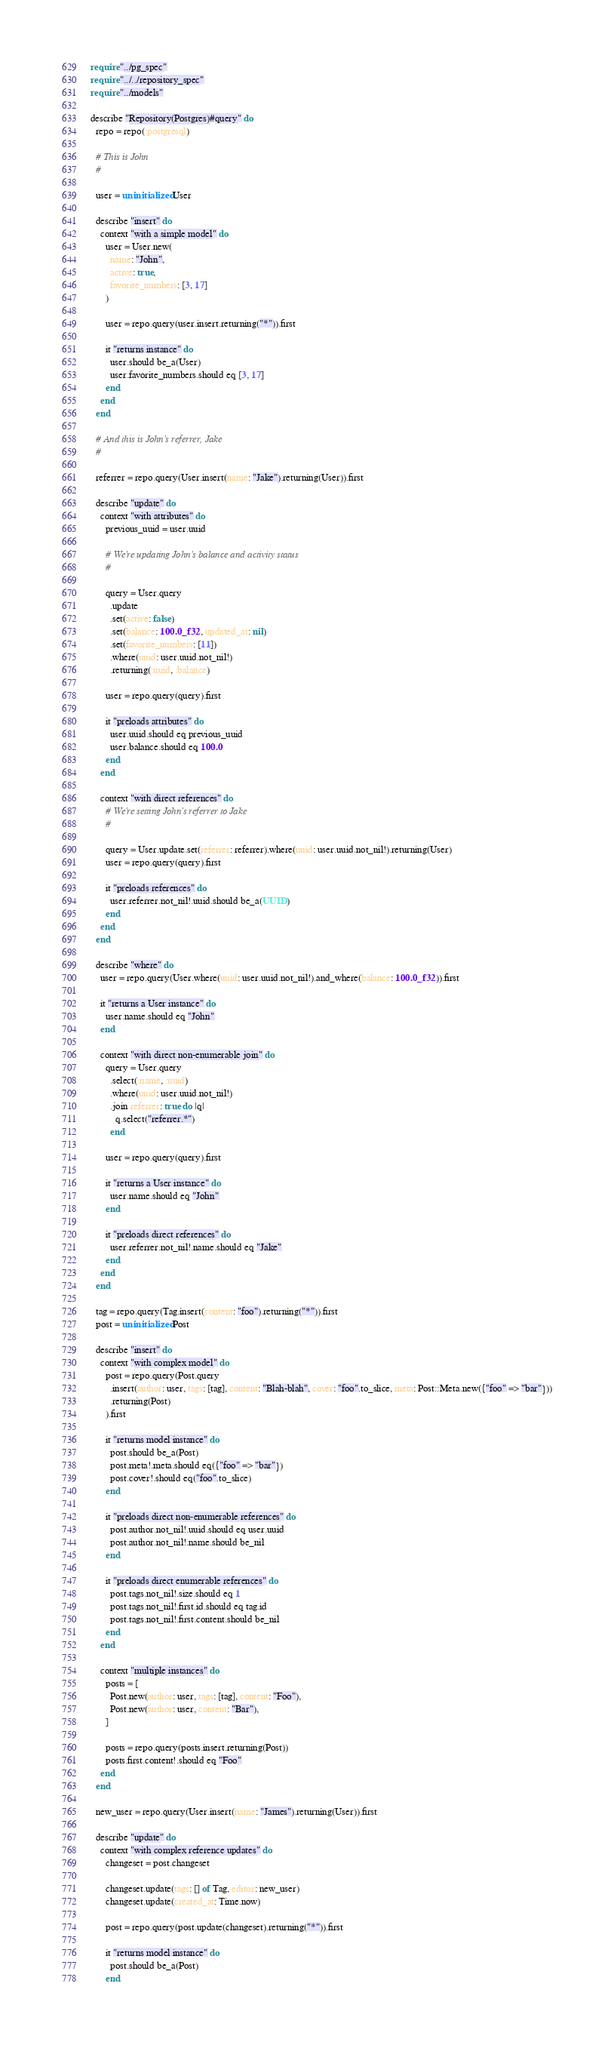Convert code to text. <code><loc_0><loc_0><loc_500><loc_500><_Crystal_>require "../pg_spec"
require "../../repository_spec"
require "../models"

describe "Repository(Postgres)#query" do
  repo = repo(:postgresql)

  # This is John
  #

  user = uninitialized User

  describe "insert" do
    context "with a simple model" do
      user = User.new(
        name: "John",
        active: true,
        favorite_numbers: [3, 17]
      )

      user = repo.query(user.insert.returning("*")).first

      it "returns instance" do
        user.should be_a(User)
        user.favorite_numbers.should eq [3, 17]
      end
    end
  end

  # And this is John's referrer, Jake
  #

  referrer = repo.query(User.insert(name: "Jake").returning(User)).first

  describe "update" do
    context "with attributes" do
      previous_uuid = user.uuid

      # We're updating John's balance and activity status
      #

      query = User.query
        .update
        .set(active: false)
        .set(balance: 100.0_f32, updated_at: nil)
        .set(favorite_numbers: [11])
        .where(uuid: user.uuid.not_nil!)
        .returning(:uuid, :balance)

      user = repo.query(query).first

      it "preloads attributes" do
        user.uuid.should eq previous_uuid
        user.balance.should eq 100.0
      end
    end

    context "with direct references" do
      # We're setting John's referrer to Jake
      #

      query = User.update.set(referrer: referrer).where(uuid: user.uuid.not_nil!).returning(User)
      user = repo.query(query).first

      it "preloads references" do
        user.referrer.not_nil!.uuid.should be_a(UUID)
      end
    end
  end

  describe "where" do
    user = repo.query(User.where(uuid: user.uuid.not_nil!).and_where(balance: 100.0_f32)).first

    it "returns a User instance" do
      user.name.should eq "John"
    end

    context "with direct non-enumerable join" do
      query = User.query
        .select(:name, :uuid)
        .where(uuid: user.uuid.not_nil!)
        .join referrer: true do |q|
          q.select("referrer.*")
        end

      user = repo.query(query).first

      it "returns a User instance" do
        user.name.should eq "John"
      end

      it "preloads direct references" do
        user.referrer.not_nil!.name.should eq "Jake"
      end
    end
  end

  tag = repo.query(Tag.insert(content: "foo").returning("*")).first
  post = uninitialized Post

  describe "insert" do
    context "with complex model" do
      post = repo.query(Post.query
        .insert(author: user, tags: [tag], content: "Blah-blah", cover: "foo".to_slice, meta: Post::Meta.new({"foo" => "bar"}))
        .returning(Post)
      ).first

      it "returns model instance" do
        post.should be_a(Post)
        post.meta!.meta.should eq({"foo" => "bar"})
        post.cover!.should eq("foo".to_slice)
      end

      it "preloads direct non-enumerable references" do
        post.author.not_nil!.uuid.should eq user.uuid
        post.author.not_nil!.name.should be_nil
      end

      it "preloads direct enumerable references" do
        post.tags.not_nil!.size.should eq 1
        post.tags.not_nil!.first.id.should eq tag.id
        post.tags.not_nil!.first.content.should be_nil
      end
    end

    context "multiple instances" do
      posts = [
        Post.new(author: user, tags: [tag], content: "Foo"),
        Post.new(author: user, content: "Bar"),
      ]

      posts = repo.query(posts.insert.returning(Post))
      posts.first.content!.should eq "Foo"
    end
  end

  new_user = repo.query(User.insert(name: "James").returning(User)).first

  describe "update" do
    context "with complex reference updates" do
      changeset = post.changeset

      changeset.update(tags: [] of Tag, editor: new_user)
      changeset.update(created_at: Time.now)

      post = repo.query(post.update(changeset).returning("*")).first

      it "returns model instance" do
        post.should be_a(Post)
      end
</code> 